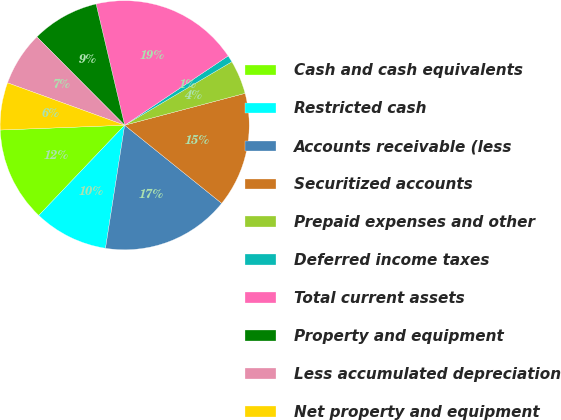<chart> <loc_0><loc_0><loc_500><loc_500><pie_chart><fcel>Cash and cash equivalents<fcel>Restricted cash<fcel>Accounts receivable (less<fcel>Securitized accounts<fcel>Prepaid expenses and other<fcel>Deferred income taxes<fcel>Total current assets<fcel>Property and equipment<fcel>Less accumulated depreciation<fcel>Net property and equipment<nl><fcel>12.28%<fcel>9.65%<fcel>16.67%<fcel>14.91%<fcel>4.39%<fcel>0.88%<fcel>19.3%<fcel>8.77%<fcel>7.02%<fcel>6.14%<nl></chart> 